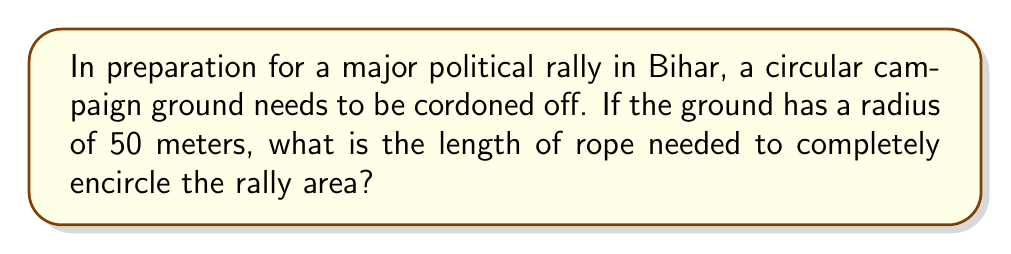Teach me how to tackle this problem. To solve this problem, we need to calculate the perimeter of a circle, which is also known as its circumference. The formula for the circumference of a circle is:

$$C = 2\pi r$$

Where:
$C$ = circumference
$\pi$ = pi (approximately 3.14159)
$r$ = radius of the circle

Given:
- The radius of the campaign ground is 50 meters

Step 1: Substitute the given radius into the formula
$$C = 2\pi (50)$$

Step 2: Multiply
$$C = 100\pi$$

Step 3: Calculate the final value (using $\pi \approx 3.14159$)
$$C \approx 100 * 3.14159 = 314.159\text{ meters}$$

Therefore, approximately 314.159 meters of rope will be needed to encircle the campaign rally ground.
Answer: $314.159\text{ meters}$ 